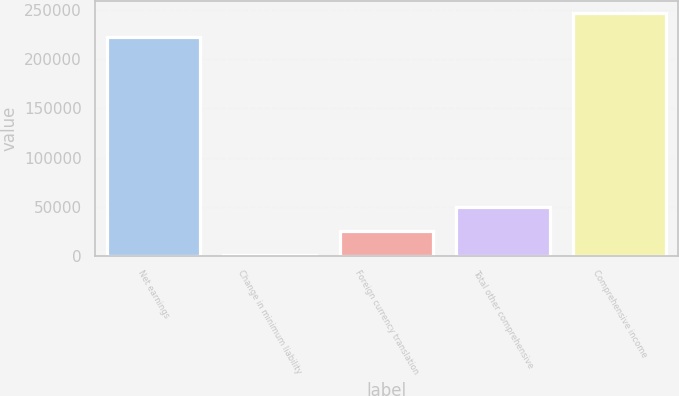Convert chart to OTSL. <chart><loc_0><loc_0><loc_500><loc_500><bar_chart><fcel>Net earnings<fcel>Change in minimum liability<fcel>Foreign currency translation<fcel>Total other comprehensive<fcel>Comprehensive income<nl><fcel>222398<fcel>745<fcel>25063.8<fcel>49382.6<fcel>246717<nl></chart> 